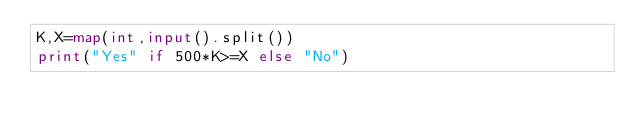<code> <loc_0><loc_0><loc_500><loc_500><_Python_>K,X=map(int,input().split())
print("Yes" if 500*K>=X else "No")</code> 